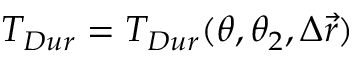<formula> <loc_0><loc_0><loc_500><loc_500>T _ { D u r } = T _ { D u r } ( \theta , \theta _ { 2 } , \Delta \vec { r } )</formula> 